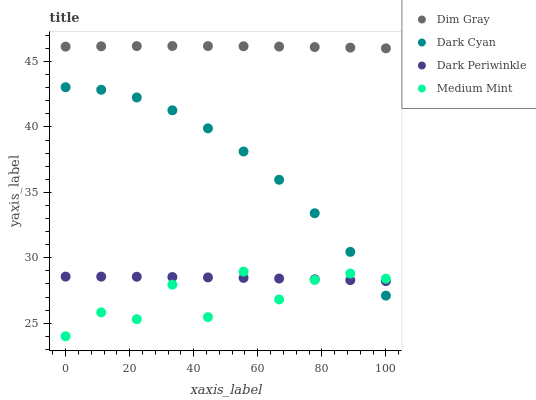Does Medium Mint have the minimum area under the curve?
Answer yes or no. Yes. Does Dim Gray have the maximum area under the curve?
Answer yes or no. Yes. Does Dim Gray have the minimum area under the curve?
Answer yes or no. No. Does Medium Mint have the maximum area under the curve?
Answer yes or no. No. Is Dark Periwinkle the smoothest?
Answer yes or no. Yes. Is Medium Mint the roughest?
Answer yes or no. Yes. Is Dim Gray the smoothest?
Answer yes or no. No. Is Dim Gray the roughest?
Answer yes or no. No. Does Medium Mint have the lowest value?
Answer yes or no. Yes. Does Dim Gray have the lowest value?
Answer yes or no. No. Does Dim Gray have the highest value?
Answer yes or no. Yes. Does Medium Mint have the highest value?
Answer yes or no. No. Is Dark Periwinkle less than Dim Gray?
Answer yes or no. Yes. Is Dim Gray greater than Medium Mint?
Answer yes or no. Yes. Does Dark Cyan intersect Dark Periwinkle?
Answer yes or no. Yes. Is Dark Cyan less than Dark Periwinkle?
Answer yes or no. No. Is Dark Cyan greater than Dark Periwinkle?
Answer yes or no. No. Does Dark Periwinkle intersect Dim Gray?
Answer yes or no. No. 